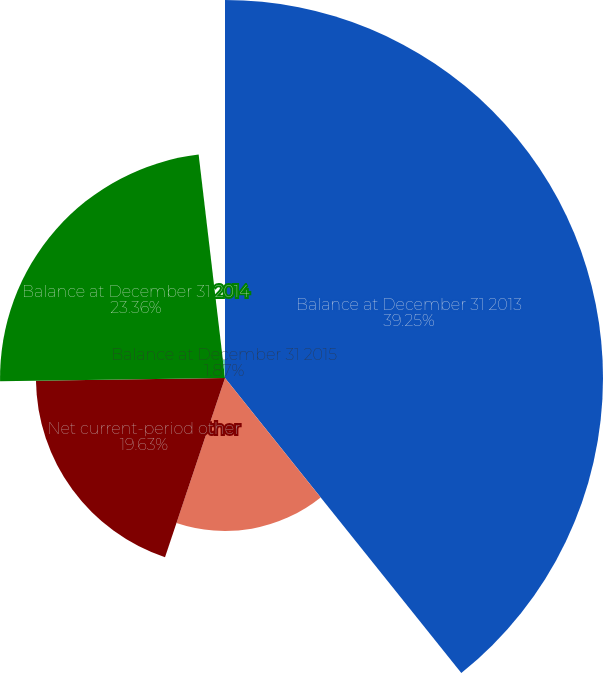<chart> <loc_0><loc_0><loc_500><loc_500><pie_chart><fcel>Balance at December 31 2013<fcel>Other comprehensive income<fcel>Net current-period other<fcel>Balance at December 31 2014<fcel>Balance at December 31 2015<nl><fcel>39.25%<fcel>15.89%<fcel>19.63%<fcel>23.36%<fcel>1.87%<nl></chart> 